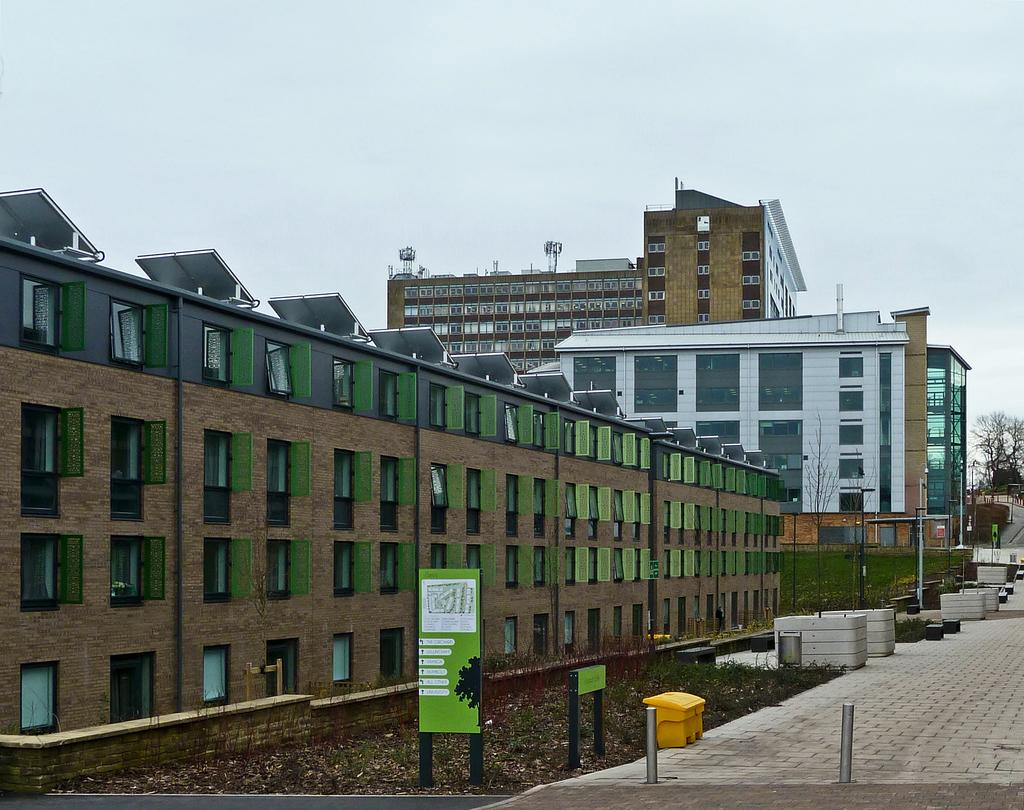What structures are located on the left side of the image? There are many buildings on the left side of the image. What can be seen on the right side of the image? There appears to be a footpath on the right side of the image. What is visible above the buildings and footpath? The sky is visible above the buildings and footpath. What type of growth can be seen on the footpath in the image? There is no growth visible on the footpath in the image. What kind of suit is the building wearing in the image? Buildings do not wear suits; they are inanimate structures. 